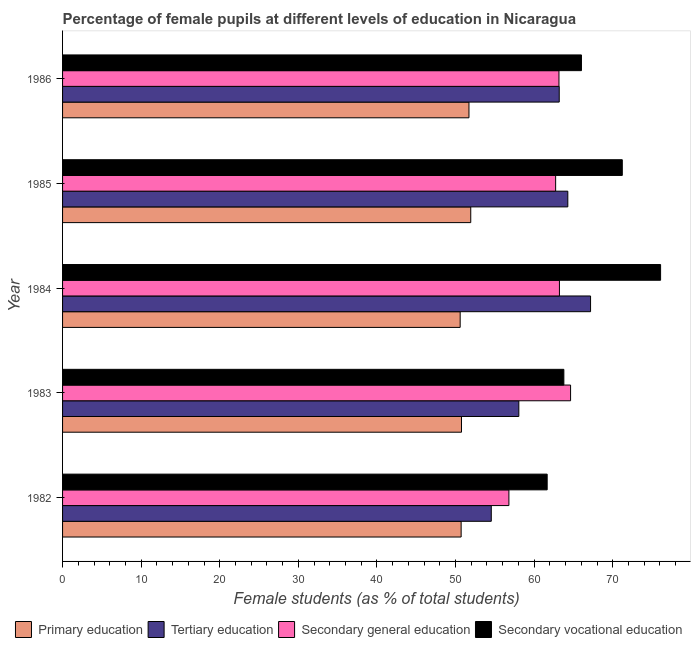Are the number of bars per tick equal to the number of legend labels?
Ensure brevity in your answer.  Yes. Are the number of bars on each tick of the Y-axis equal?
Offer a terse response. Yes. How many bars are there on the 3rd tick from the top?
Provide a succinct answer. 4. What is the label of the 1st group of bars from the top?
Give a very brief answer. 1986. In how many cases, is the number of bars for a given year not equal to the number of legend labels?
Offer a terse response. 0. What is the percentage of female students in secondary education in 1985?
Keep it short and to the point. 62.74. Across all years, what is the maximum percentage of female students in primary education?
Make the answer very short. 51.94. Across all years, what is the minimum percentage of female students in secondary vocational education?
Keep it short and to the point. 61.66. What is the total percentage of female students in tertiary education in the graph?
Your answer should be very brief. 307.26. What is the difference between the percentage of female students in tertiary education in 1983 and that in 1986?
Your answer should be compact. -5.14. What is the difference between the percentage of female students in secondary education in 1985 and the percentage of female students in primary education in 1986?
Provide a succinct answer. 11.03. What is the average percentage of female students in secondary education per year?
Provide a succinct answer. 62.11. In the year 1982, what is the difference between the percentage of female students in tertiary education and percentage of female students in secondary vocational education?
Offer a terse response. -7.11. In how many years, is the percentage of female students in primary education greater than 20 %?
Keep it short and to the point. 5. What is the ratio of the percentage of female students in secondary education in 1984 to that in 1985?
Give a very brief answer. 1.01. Is the difference between the percentage of female students in primary education in 1982 and 1983 greater than the difference between the percentage of female students in tertiary education in 1982 and 1983?
Give a very brief answer. Yes. What is the difference between the highest and the second highest percentage of female students in primary education?
Your answer should be very brief. 0.23. What is the difference between the highest and the lowest percentage of female students in tertiary education?
Give a very brief answer. 12.63. Is it the case that in every year, the sum of the percentage of female students in secondary education and percentage of female students in primary education is greater than the sum of percentage of female students in secondary vocational education and percentage of female students in tertiary education?
Ensure brevity in your answer.  No. What does the 4th bar from the top in 1982 represents?
Offer a very short reply. Primary education. What does the 2nd bar from the bottom in 1983 represents?
Give a very brief answer. Tertiary education. Is it the case that in every year, the sum of the percentage of female students in primary education and percentage of female students in tertiary education is greater than the percentage of female students in secondary education?
Give a very brief answer. Yes. Are all the bars in the graph horizontal?
Keep it short and to the point. Yes. Does the graph contain any zero values?
Keep it short and to the point. No. Where does the legend appear in the graph?
Your answer should be very brief. Bottom center. How many legend labels are there?
Your answer should be compact. 4. How are the legend labels stacked?
Offer a very short reply. Horizontal. What is the title of the graph?
Offer a terse response. Percentage of female pupils at different levels of education in Nicaragua. What is the label or title of the X-axis?
Keep it short and to the point. Female students (as % of total students). What is the label or title of the Y-axis?
Your answer should be very brief. Year. What is the Female students (as % of total students) in Primary education in 1982?
Your answer should be compact. 50.71. What is the Female students (as % of total students) in Tertiary education in 1982?
Your answer should be very brief. 54.55. What is the Female students (as % of total students) in Secondary general education in 1982?
Offer a terse response. 56.79. What is the Female students (as % of total students) in Secondary vocational education in 1982?
Keep it short and to the point. 61.66. What is the Female students (as % of total students) in Primary education in 1983?
Give a very brief answer. 50.76. What is the Female students (as % of total students) of Tertiary education in 1983?
Ensure brevity in your answer.  58.05. What is the Female students (as % of total students) in Secondary general education in 1983?
Offer a very short reply. 64.64. What is the Female students (as % of total students) of Secondary vocational education in 1983?
Offer a very short reply. 63.78. What is the Female students (as % of total students) of Primary education in 1984?
Provide a short and direct response. 50.59. What is the Female students (as % of total students) of Tertiary education in 1984?
Offer a very short reply. 67.18. What is the Female students (as % of total students) in Secondary general education in 1984?
Make the answer very short. 63.22. What is the Female students (as % of total students) of Secondary vocational education in 1984?
Offer a terse response. 76.09. What is the Female students (as % of total students) of Primary education in 1985?
Keep it short and to the point. 51.94. What is the Female students (as % of total students) in Tertiary education in 1985?
Provide a succinct answer. 64.28. What is the Female students (as % of total students) of Secondary general education in 1985?
Provide a succinct answer. 62.74. What is the Female students (as % of total students) in Secondary vocational education in 1985?
Your answer should be very brief. 71.22. What is the Female students (as % of total students) of Primary education in 1986?
Your response must be concise. 51.71. What is the Female students (as % of total students) in Tertiary education in 1986?
Offer a very short reply. 63.19. What is the Female students (as % of total students) in Secondary general education in 1986?
Your response must be concise. 63.16. What is the Female students (as % of total students) in Secondary vocational education in 1986?
Your answer should be compact. 66.02. Across all years, what is the maximum Female students (as % of total students) of Primary education?
Ensure brevity in your answer.  51.94. Across all years, what is the maximum Female students (as % of total students) in Tertiary education?
Make the answer very short. 67.18. Across all years, what is the maximum Female students (as % of total students) in Secondary general education?
Provide a short and direct response. 64.64. Across all years, what is the maximum Female students (as % of total students) in Secondary vocational education?
Your answer should be very brief. 76.09. Across all years, what is the minimum Female students (as % of total students) of Primary education?
Provide a succinct answer. 50.59. Across all years, what is the minimum Female students (as % of total students) in Tertiary education?
Give a very brief answer. 54.55. Across all years, what is the minimum Female students (as % of total students) in Secondary general education?
Offer a terse response. 56.79. Across all years, what is the minimum Female students (as % of total students) in Secondary vocational education?
Provide a short and direct response. 61.66. What is the total Female students (as % of total students) in Primary education in the graph?
Provide a short and direct response. 255.7. What is the total Female students (as % of total students) in Tertiary education in the graph?
Give a very brief answer. 307.26. What is the total Female students (as % of total students) of Secondary general education in the graph?
Make the answer very short. 310.54. What is the total Female students (as % of total students) of Secondary vocational education in the graph?
Your answer should be very brief. 338.77. What is the difference between the Female students (as % of total students) of Primary education in 1982 and that in 1983?
Give a very brief answer. -0.05. What is the difference between the Female students (as % of total students) of Tertiary education in 1982 and that in 1983?
Make the answer very short. -3.5. What is the difference between the Female students (as % of total students) of Secondary general education in 1982 and that in 1983?
Ensure brevity in your answer.  -7.85. What is the difference between the Female students (as % of total students) in Secondary vocational education in 1982 and that in 1983?
Your response must be concise. -2.12. What is the difference between the Female students (as % of total students) in Primary education in 1982 and that in 1984?
Offer a very short reply. 0.12. What is the difference between the Female students (as % of total students) of Tertiary education in 1982 and that in 1984?
Your answer should be very brief. -12.63. What is the difference between the Female students (as % of total students) in Secondary general education in 1982 and that in 1984?
Ensure brevity in your answer.  -6.43. What is the difference between the Female students (as % of total students) in Secondary vocational education in 1982 and that in 1984?
Offer a very short reply. -14.43. What is the difference between the Female students (as % of total students) of Primary education in 1982 and that in 1985?
Make the answer very short. -1.22. What is the difference between the Female students (as % of total students) of Tertiary education in 1982 and that in 1985?
Offer a very short reply. -9.74. What is the difference between the Female students (as % of total students) in Secondary general education in 1982 and that in 1985?
Give a very brief answer. -5.95. What is the difference between the Female students (as % of total students) of Secondary vocational education in 1982 and that in 1985?
Your answer should be very brief. -9.56. What is the difference between the Female students (as % of total students) of Primary education in 1982 and that in 1986?
Provide a short and direct response. -1. What is the difference between the Female students (as % of total students) in Tertiary education in 1982 and that in 1986?
Offer a very short reply. -8.65. What is the difference between the Female students (as % of total students) of Secondary general education in 1982 and that in 1986?
Make the answer very short. -6.37. What is the difference between the Female students (as % of total students) in Secondary vocational education in 1982 and that in 1986?
Provide a succinct answer. -4.36. What is the difference between the Female students (as % of total students) of Primary education in 1983 and that in 1984?
Ensure brevity in your answer.  0.17. What is the difference between the Female students (as % of total students) of Tertiary education in 1983 and that in 1984?
Make the answer very short. -9.13. What is the difference between the Female students (as % of total students) in Secondary general education in 1983 and that in 1984?
Offer a terse response. 1.42. What is the difference between the Female students (as % of total students) of Secondary vocational education in 1983 and that in 1984?
Your answer should be very brief. -12.31. What is the difference between the Female students (as % of total students) in Primary education in 1983 and that in 1985?
Your response must be concise. -1.18. What is the difference between the Female students (as % of total students) in Tertiary education in 1983 and that in 1985?
Your answer should be compact. -6.23. What is the difference between the Female students (as % of total students) of Secondary general education in 1983 and that in 1985?
Ensure brevity in your answer.  1.9. What is the difference between the Female students (as % of total students) of Secondary vocational education in 1983 and that in 1985?
Make the answer very short. -7.43. What is the difference between the Female students (as % of total students) in Primary education in 1983 and that in 1986?
Ensure brevity in your answer.  -0.95. What is the difference between the Female students (as % of total students) of Tertiary education in 1983 and that in 1986?
Offer a terse response. -5.14. What is the difference between the Female students (as % of total students) of Secondary general education in 1983 and that in 1986?
Keep it short and to the point. 1.48. What is the difference between the Female students (as % of total students) of Secondary vocational education in 1983 and that in 1986?
Keep it short and to the point. -2.24. What is the difference between the Female students (as % of total students) of Primary education in 1984 and that in 1985?
Make the answer very short. -1.35. What is the difference between the Female students (as % of total students) of Tertiary education in 1984 and that in 1985?
Your response must be concise. 2.89. What is the difference between the Female students (as % of total students) of Secondary general education in 1984 and that in 1985?
Your answer should be compact. 0.48. What is the difference between the Female students (as % of total students) of Secondary vocational education in 1984 and that in 1985?
Provide a succinct answer. 4.87. What is the difference between the Female students (as % of total students) in Primary education in 1984 and that in 1986?
Ensure brevity in your answer.  -1.12. What is the difference between the Female students (as % of total students) of Tertiary education in 1984 and that in 1986?
Offer a very short reply. 3.98. What is the difference between the Female students (as % of total students) of Secondary general education in 1984 and that in 1986?
Your response must be concise. 0.06. What is the difference between the Female students (as % of total students) in Secondary vocational education in 1984 and that in 1986?
Offer a very short reply. 10.07. What is the difference between the Female students (as % of total students) in Primary education in 1985 and that in 1986?
Your response must be concise. 0.23. What is the difference between the Female students (as % of total students) of Tertiary education in 1985 and that in 1986?
Make the answer very short. 1.09. What is the difference between the Female students (as % of total students) in Secondary general education in 1985 and that in 1986?
Offer a very short reply. -0.42. What is the difference between the Female students (as % of total students) in Secondary vocational education in 1985 and that in 1986?
Give a very brief answer. 5.2. What is the difference between the Female students (as % of total students) of Primary education in 1982 and the Female students (as % of total students) of Tertiary education in 1983?
Keep it short and to the point. -7.34. What is the difference between the Female students (as % of total students) of Primary education in 1982 and the Female students (as % of total students) of Secondary general education in 1983?
Offer a terse response. -13.93. What is the difference between the Female students (as % of total students) of Primary education in 1982 and the Female students (as % of total students) of Secondary vocational education in 1983?
Keep it short and to the point. -13.07. What is the difference between the Female students (as % of total students) of Tertiary education in 1982 and the Female students (as % of total students) of Secondary general education in 1983?
Offer a very short reply. -10.09. What is the difference between the Female students (as % of total students) in Tertiary education in 1982 and the Female students (as % of total students) in Secondary vocational education in 1983?
Offer a terse response. -9.23. What is the difference between the Female students (as % of total students) of Secondary general education in 1982 and the Female students (as % of total students) of Secondary vocational education in 1983?
Your answer should be compact. -6.99. What is the difference between the Female students (as % of total students) of Primary education in 1982 and the Female students (as % of total students) of Tertiary education in 1984?
Keep it short and to the point. -16.47. What is the difference between the Female students (as % of total students) in Primary education in 1982 and the Female students (as % of total students) in Secondary general education in 1984?
Provide a short and direct response. -12.51. What is the difference between the Female students (as % of total students) of Primary education in 1982 and the Female students (as % of total students) of Secondary vocational education in 1984?
Offer a very short reply. -25.38. What is the difference between the Female students (as % of total students) of Tertiary education in 1982 and the Female students (as % of total students) of Secondary general education in 1984?
Give a very brief answer. -8.67. What is the difference between the Female students (as % of total students) in Tertiary education in 1982 and the Female students (as % of total students) in Secondary vocational education in 1984?
Keep it short and to the point. -21.54. What is the difference between the Female students (as % of total students) of Secondary general education in 1982 and the Female students (as % of total students) of Secondary vocational education in 1984?
Give a very brief answer. -19.3. What is the difference between the Female students (as % of total students) of Primary education in 1982 and the Female students (as % of total students) of Tertiary education in 1985?
Give a very brief answer. -13.57. What is the difference between the Female students (as % of total students) of Primary education in 1982 and the Female students (as % of total students) of Secondary general education in 1985?
Keep it short and to the point. -12.03. What is the difference between the Female students (as % of total students) in Primary education in 1982 and the Female students (as % of total students) in Secondary vocational education in 1985?
Provide a succinct answer. -20.5. What is the difference between the Female students (as % of total students) in Tertiary education in 1982 and the Female students (as % of total students) in Secondary general education in 1985?
Offer a very short reply. -8.19. What is the difference between the Female students (as % of total students) in Tertiary education in 1982 and the Female students (as % of total students) in Secondary vocational education in 1985?
Ensure brevity in your answer.  -16.67. What is the difference between the Female students (as % of total students) of Secondary general education in 1982 and the Female students (as % of total students) of Secondary vocational education in 1985?
Your answer should be very brief. -14.43. What is the difference between the Female students (as % of total students) of Primary education in 1982 and the Female students (as % of total students) of Tertiary education in 1986?
Offer a terse response. -12.48. What is the difference between the Female students (as % of total students) in Primary education in 1982 and the Female students (as % of total students) in Secondary general education in 1986?
Your answer should be compact. -12.45. What is the difference between the Female students (as % of total students) in Primary education in 1982 and the Female students (as % of total students) in Secondary vocational education in 1986?
Offer a very short reply. -15.31. What is the difference between the Female students (as % of total students) of Tertiary education in 1982 and the Female students (as % of total students) of Secondary general education in 1986?
Give a very brief answer. -8.61. What is the difference between the Female students (as % of total students) of Tertiary education in 1982 and the Female students (as % of total students) of Secondary vocational education in 1986?
Provide a short and direct response. -11.47. What is the difference between the Female students (as % of total students) of Secondary general education in 1982 and the Female students (as % of total students) of Secondary vocational education in 1986?
Provide a succinct answer. -9.23. What is the difference between the Female students (as % of total students) of Primary education in 1983 and the Female students (as % of total students) of Tertiary education in 1984?
Ensure brevity in your answer.  -16.42. What is the difference between the Female students (as % of total students) in Primary education in 1983 and the Female students (as % of total students) in Secondary general education in 1984?
Your response must be concise. -12.46. What is the difference between the Female students (as % of total students) of Primary education in 1983 and the Female students (as % of total students) of Secondary vocational education in 1984?
Offer a terse response. -25.33. What is the difference between the Female students (as % of total students) of Tertiary education in 1983 and the Female students (as % of total students) of Secondary general education in 1984?
Keep it short and to the point. -5.17. What is the difference between the Female students (as % of total students) of Tertiary education in 1983 and the Female students (as % of total students) of Secondary vocational education in 1984?
Ensure brevity in your answer.  -18.04. What is the difference between the Female students (as % of total students) in Secondary general education in 1983 and the Female students (as % of total students) in Secondary vocational education in 1984?
Your answer should be very brief. -11.45. What is the difference between the Female students (as % of total students) in Primary education in 1983 and the Female students (as % of total students) in Tertiary education in 1985?
Offer a very short reply. -13.53. What is the difference between the Female students (as % of total students) of Primary education in 1983 and the Female students (as % of total students) of Secondary general education in 1985?
Your answer should be very brief. -11.98. What is the difference between the Female students (as % of total students) in Primary education in 1983 and the Female students (as % of total students) in Secondary vocational education in 1985?
Your response must be concise. -20.46. What is the difference between the Female students (as % of total students) of Tertiary education in 1983 and the Female students (as % of total students) of Secondary general education in 1985?
Make the answer very short. -4.68. What is the difference between the Female students (as % of total students) of Tertiary education in 1983 and the Female students (as % of total students) of Secondary vocational education in 1985?
Your answer should be compact. -13.16. What is the difference between the Female students (as % of total students) of Secondary general education in 1983 and the Female students (as % of total students) of Secondary vocational education in 1985?
Provide a short and direct response. -6.58. What is the difference between the Female students (as % of total students) in Primary education in 1983 and the Female students (as % of total students) in Tertiary education in 1986?
Offer a very short reply. -12.44. What is the difference between the Female students (as % of total students) of Primary education in 1983 and the Female students (as % of total students) of Secondary general education in 1986?
Provide a short and direct response. -12.4. What is the difference between the Female students (as % of total students) in Primary education in 1983 and the Female students (as % of total students) in Secondary vocational education in 1986?
Offer a terse response. -15.26. What is the difference between the Female students (as % of total students) in Tertiary education in 1983 and the Female students (as % of total students) in Secondary general education in 1986?
Offer a terse response. -5.11. What is the difference between the Female students (as % of total students) of Tertiary education in 1983 and the Female students (as % of total students) of Secondary vocational education in 1986?
Your answer should be compact. -7.97. What is the difference between the Female students (as % of total students) of Secondary general education in 1983 and the Female students (as % of total students) of Secondary vocational education in 1986?
Your response must be concise. -1.38. What is the difference between the Female students (as % of total students) in Primary education in 1984 and the Female students (as % of total students) in Tertiary education in 1985?
Provide a short and direct response. -13.69. What is the difference between the Female students (as % of total students) of Primary education in 1984 and the Female students (as % of total students) of Secondary general education in 1985?
Give a very brief answer. -12.15. What is the difference between the Female students (as % of total students) in Primary education in 1984 and the Female students (as % of total students) in Secondary vocational education in 1985?
Offer a very short reply. -20.63. What is the difference between the Female students (as % of total students) in Tertiary education in 1984 and the Female students (as % of total students) in Secondary general education in 1985?
Keep it short and to the point. 4.44. What is the difference between the Female students (as % of total students) in Tertiary education in 1984 and the Female students (as % of total students) in Secondary vocational education in 1985?
Your response must be concise. -4.04. What is the difference between the Female students (as % of total students) in Secondary general education in 1984 and the Female students (as % of total students) in Secondary vocational education in 1985?
Offer a very short reply. -8. What is the difference between the Female students (as % of total students) in Primary education in 1984 and the Female students (as % of total students) in Tertiary education in 1986?
Give a very brief answer. -12.6. What is the difference between the Female students (as % of total students) in Primary education in 1984 and the Female students (as % of total students) in Secondary general education in 1986?
Offer a very short reply. -12.57. What is the difference between the Female students (as % of total students) of Primary education in 1984 and the Female students (as % of total students) of Secondary vocational education in 1986?
Provide a short and direct response. -15.43. What is the difference between the Female students (as % of total students) in Tertiary education in 1984 and the Female students (as % of total students) in Secondary general education in 1986?
Provide a short and direct response. 4.02. What is the difference between the Female students (as % of total students) of Tertiary education in 1984 and the Female students (as % of total students) of Secondary vocational education in 1986?
Provide a short and direct response. 1.16. What is the difference between the Female students (as % of total students) in Secondary general education in 1984 and the Female students (as % of total students) in Secondary vocational education in 1986?
Provide a succinct answer. -2.8. What is the difference between the Female students (as % of total students) of Primary education in 1985 and the Female students (as % of total students) of Tertiary education in 1986?
Your answer should be compact. -11.26. What is the difference between the Female students (as % of total students) of Primary education in 1985 and the Female students (as % of total students) of Secondary general education in 1986?
Your response must be concise. -11.22. What is the difference between the Female students (as % of total students) in Primary education in 1985 and the Female students (as % of total students) in Secondary vocational education in 1986?
Offer a very short reply. -14.08. What is the difference between the Female students (as % of total students) in Tertiary education in 1985 and the Female students (as % of total students) in Secondary general education in 1986?
Your answer should be compact. 1.13. What is the difference between the Female students (as % of total students) in Tertiary education in 1985 and the Female students (as % of total students) in Secondary vocational education in 1986?
Offer a terse response. -1.74. What is the difference between the Female students (as % of total students) of Secondary general education in 1985 and the Female students (as % of total students) of Secondary vocational education in 1986?
Ensure brevity in your answer.  -3.28. What is the average Female students (as % of total students) in Primary education per year?
Offer a very short reply. 51.14. What is the average Female students (as % of total students) in Tertiary education per year?
Your answer should be compact. 61.45. What is the average Female students (as % of total students) of Secondary general education per year?
Provide a short and direct response. 62.11. What is the average Female students (as % of total students) in Secondary vocational education per year?
Provide a succinct answer. 67.75. In the year 1982, what is the difference between the Female students (as % of total students) in Primary education and Female students (as % of total students) in Tertiary education?
Make the answer very short. -3.84. In the year 1982, what is the difference between the Female students (as % of total students) of Primary education and Female students (as % of total students) of Secondary general education?
Provide a short and direct response. -6.08. In the year 1982, what is the difference between the Female students (as % of total students) of Primary education and Female students (as % of total students) of Secondary vocational education?
Your answer should be very brief. -10.95. In the year 1982, what is the difference between the Female students (as % of total students) in Tertiary education and Female students (as % of total students) in Secondary general education?
Offer a terse response. -2.24. In the year 1982, what is the difference between the Female students (as % of total students) of Tertiary education and Female students (as % of total students) of Secondary vocational education?
Your response must be concise. -7.11. In the year 1982, what is the difference between the Female students (as % of total students) of Secondary general education and Female students (as % of total students) of Secondary vocational education?
Ensure brevity in your answer.  -4.87. In the year 1983, what is the difference between the Female students (as % of total students) of Primary education and Female students (as % of total students) of Tertiary education?
Ensure brevity in your answer.  -7.3. In the year 1983, what is the difference between the Female students (as % of total students) of Primary education and Female students (as % of total students) of Secondary general education?
Offer a terse response. -13.88. In the year 1983, what is the difference between the Female students (as % of total students) of Primary education and Female students (as % of total students) of Secondary vocational education?
Your answer should be compact. -13.03. In the year 1983, what is the difference between the Female students (as % of total students) of Tertiary education and Female students (as % of total students) of Secondary general education?
Give a very brief answer. -6.58. In the year 1983, what is the difference between the Female students (as % of total students) in Tertiary education and Female students (as % of total students) in Secondary vocational education?
Your response must be concise. -5.73. In the year 1983, what is the difference between the Female students (as % of total students) in Secondary general education and Female students (as % of total students) in Secondary vocational education?
Give a very brief answer. 0.85. In the year 1984, what is the difference between the Female students (as % of total students) in Primary education and Female students (as % of total students) in Tertiary education?
Give a very brief answer. -16.59. In the year 1984, what is the difference between the Female students (as % of total students) of Primary education and Female students (as % of total students) of Secondary general education?
Your answer should be very brief. -12.63. In the year 1984, what is the difference between the Female students (as % of total students) in Primary education and Female students (as % of total students) in Secondary vocational education?
Give a very brief answer. -25.5. In the year 1984, what is the difference between the Female students (as % of total students) in Tertiary education and Female students (as % of total students) in Secondary general education?
Provide a short and direct response. 3.96. In the year 1984, what is the difference between the Female students (as % of total students) of Tertiary education and Female students (as % of total students) of Secondary vocational education?
Your answer should be compact. -8.91. In the year 1984, what is the difference between the Female students (as % of total students) of Secondary general education and Female students (as % of total students) of Secondary vocational education?
Your response must be concise. -12.87. In the year 1985, what is the difference between the Female students (as % of total students) of Primary education and Female students (as % of total students) of Tertiary education?
Make the answer very short. -12.35. In the year 1985, what is the difference between the Female students (as % of total students) of Primary education and Female students (as % of total students) of Secondary general education?
Your answer should be compact. -10.8. In the year 1985, what is the difference between the Female students (as % of total students) of Primary education and Female students (as % of total students) of Secondary vocational education?
Offer a very short reply. -19.28. In the year 1985, what is the difference between the Female students (as % of total students) in Tertiary education and Female students (as % of total students) in Secondary general education?
Offer a terse response. 1.55. In the year 1985, what is the difference between the Female students (as % of total students) of Tertiary education and Female students (as % of total students) of Secondary vocational education?
Provide a short and direct response. -6.93. In the year 1985, what is the difference between the Female students (as % of total students) in Secondary general education and Female students (as % of total students) in Secondary vocational education?
Offer a very short reply. -8.48. In the year 1986, what is the difference between the Female students (as % of total students) in Primary education and Female students (as % of total students) in Tertiary education?
Give a very brief answer. -11.49. In the year 1986, what is the difference between the Female students (as % of total students) of Primary education and Female students (as % of total students) of Secondary general education?
Offer a very short reply. -11.45. In the year 1986, what is the difference between the Female students (as % of total students) of Primary education and Female students (as % of total students) of Secondary vocational education?
Keep it short and to the point. -14.31. In the year 1986, what is the difference between the Female students (as % of total students) in Tertiary education and Female students (as % of total students) in Secondary general education?
Give a very brief answer. 0.04. In the year 1986, what is the difference between the Female students (as % of total students) in Tertiary education and Female students (as % of total students) in Secondary vocational education?
Provide a short and direct response. -2.83. In the year 1986, what is the difference between the Female students (as % of total students) in Secondary general education and Female students (as % of total students) in Secondary vocational education?
Offer a terse response. -2.86. What is the ratio of the Female students (as % of total students) of Primary education in 1982 to that in 1983?
Give a very brief answer. 1. What is the ratio of the Female students (as % of total students) in Tertiary education in 1982 to that in 1983?
Offer a terse response. 0.94. What is the ratio of the Female students (as % of total students) in Secondary general education in 1982 to that in 1983?
Ensure brevity in your answer.  0.88. What is the ratio of the Female students (as % of total students) of Secondary vocational education in 1982 to that in 1983?
Your response must be concise. 0.97. What is the ratio of the Female students (as % of total students) in Primary education in 1982 to that in 1984?
Give a very brief answer. 1. What is the ratio of the Female students (as % of total students) of Tertiary education in 1982 to that in 1984?
Your answer should be very brief. 0.81. What is the ratio of the Female students (as % of total students) in Secondary general education in 1982 to that in 1984?
Your answer should be compact. 0.9. What is the ratio of the Female students (as % of total students) of Secondary vocational education in 1982 to that in 1984?
Provide a succinct answer. 0.81. What is the ratio of the Female students (as % of total students) in Primary education in 1982 to that in 1985?
Offer a terse response. 0.98. What is the ratio of the Female students (as % of total students) in Tertiary education in 1982 to that in 1985?
Provide a short and direct response. 0.85. What is the ratio of the Female students (as % of total students) in Secondary general education in 1982 to that in 1985?
Your response must be concise. 0.91. What is the ratio of the Female students (as % of total students) of Secondary vocational education in 1982 to that in 1985?
Give a very brief answer. 0.87. What is the ratio of the Female students (as % of total students) in Primary education in 1982 to that in 1986?
Offer a terse response. 0.98. What is the ratio of the Female students (as % of total students) of Tertiary education in 1982 to that in 1986?
Your response must be concise. 0.86. What is the ratio of the Female students (as % of total students) in Secondary general education in 1982 to that in 1986?
Your answer should be very brief. 0.9. What is the ratio of the Female students (as % of total students) in Secondary vocational education in 1982 to that in 1986?
Make the answer very short. 0.93. What is the ratio of the Female students (as % of total students) of Primary education in 1983 to that in 1984?
Ensure brevity in your answer.  1. What is the ratio of the Female students (as % of total students) of Tertiary education in 1983 to that in 1984?
Provide a short and direct response. 0.86. What is the ratio of the Female students (as % of total students) in Secondary general education in 1983 to that in 1984?
Provide a succinct answer. 1.02. What is the ratio of the Female students (as % of total students) in Secondary vocational education in 1983 to that in 1984?
Ensure brevity in your answer.  0.84. What is the ratio of the Female students (as % of total students) in Primary education in 1983 to that in 1985?
Offer a terse response. 0.98. What is the ratio of the Female students (as % of total students) in Tertiary education in 1983 to that in 1985?
Offer a very short reply. 0.9. What is the ratio of the Female students (as % of total students) of Secondary general education in 1983 to that in 1985?
Your response must be concise. 1.03. What is the ratio of the Female students (as % of total students) of Secondary vocational education in 1983 to that in 1985?
Keep it short and to the point. 0.9. What is the ratio of the Female students (as % of total students) of Primary education in 1983 to that in 1986?
Provide a succinct answer. 0.98. What is the ratio of the Female students (as % of total students) of Tertiary education in 1983 to that in 1986?
Make the answer very short. 0.92. What is the ratio of the Female students (as % of total students) in Secondary general education in 1983 to that in 1986?
Offer a terse response. 1.02. What is the ratio of the Female students (as % of total students) of Secondary vocational education in 1983 to that in 1986?
Offer a terse response. 0.97. What is the ratio of the Female students (as % of total students) of Primary education in 1984 to that in 1985?
Keep it short and to the point. 0.97. What is the ratio of the Female students (as % of total students) of Tertiary education in 1984 to that in 1985?
Your answer should be very brief. 1.04. What is the ratio of the Female students (as % of total students) in Secondary general education in 1984 to that in 1985?
Keep it short and to the point. 1.01. What is the ratio of the Female students (as % of total students) in Secondary vocational education in 1984 to that in 1985?
Offer a terse response. 1.07. What is the ratio of the Female students (as % of total students) in Primary education in 1984 to that in 1986?
Offer a very short reply. 0.98. What is the ratio of the Female students (as % of total students) of Tertiary education in 1984 to that in 1986?
Your answer should be compact. 1.06. What is the ratio of the Female students (as % of total students) in Secondary general education in 1984 to that in 1986?
Offer a very short reply. 1. What is the ratio of the Female students (as % of total students) in Secondary vocational education in 1984 to that in 1986?
Keep it short and to the point. 1.15. What is the ratio of the Female students (as % of total students) in Tertiary education in 1985 to that in 1986?
Offer a very short reply. 1.02. What is the ratio of the Female students (as % of total students) in Secondary general education in 1985 to that in 1986?
Make the answer very short. 0.99. What is the ratio of the Female students (as % of total students) in Secondary vocational education in 1985 to that in 1986?
Provide a succinct answer. 1.08. What is the difference between the highest and the second highest Female students (as % of total students) of Primary education?
Provide a succinct answer. 0.23. What is the difference between the highest and the second highest Female students (as % of total students) in Tertiary education?
Ensure brevity in your answer.  2.89. What is the difference between the highest and the second highest Female students (as % of total students) in Secondary general education?
Your answer should be very brief. 1.42. What is the difference between the highest and the second highest Female students (as % of total students) of Secondary vocational education?
Provide a succinct answer. 4.87. What is the difference between the highest and the lowest Female students (as % of total students) of Primary education?
Offer a terse response. 1.35. What is the difference between the highest and the lowest Female students (as % of total students) in Tertiary education?
Your answer should be very brief. 12.63. What is the difference between the highest and the lowest Female students (as % of total students) in Secondary general education?
Ensure brevity in your answer.  7.85. What is the difference between the highest and the lowest Female students (as % of total students) in Secondary vocational education?
Your answer should be very brief. 14.43. 